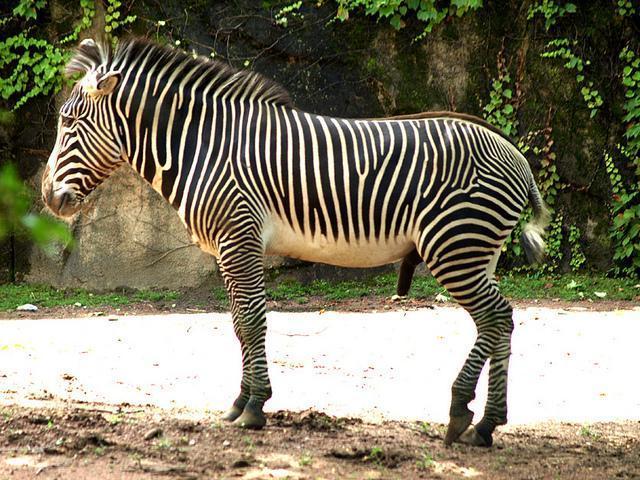How many zebras are in the picture?
Give a very brief answer. 1. 